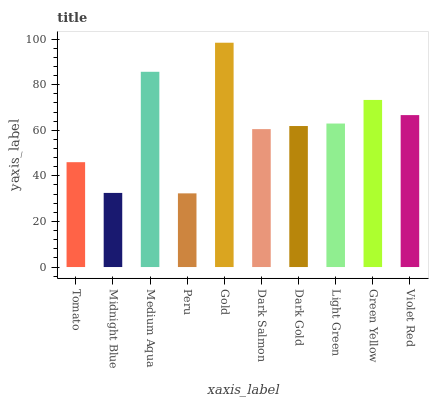Is Peru the minimum?
Answer yes or no. Yes. Is Gold the maximum?
Answer yes or no. Yes. Is Midnight Blue the minimum?
Answer yes or no. No. Is Midnight Blue the maximum?
Answer yes or no. No. Is Tomato greater than Midnight Blue?
Answer yes or no. Yes. Is Midnight Blue less than Tomato?
Answer yes or no. Yes. Is Midnight Blue greater than Tomato?
Answer yes or no. No. Is Tomato less than Midnight Blue?
Answer yes or no. No. Is Light Green the high median?
Answer yes or no. Yes. Is Dark Gold the low median?
Answer yes or no. Yes. Is Peru the high median?
Answer yes or no. No. Is Light Green the low median?
Answer yes or no. No. 